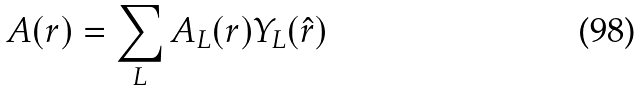<formula> <loc_0><loc_0><loc_500><loc_500>A ( { r } ) = \sum _ { L } A _ { L } ( r ) Y _ { L } ( \hat { r } )</formula> 